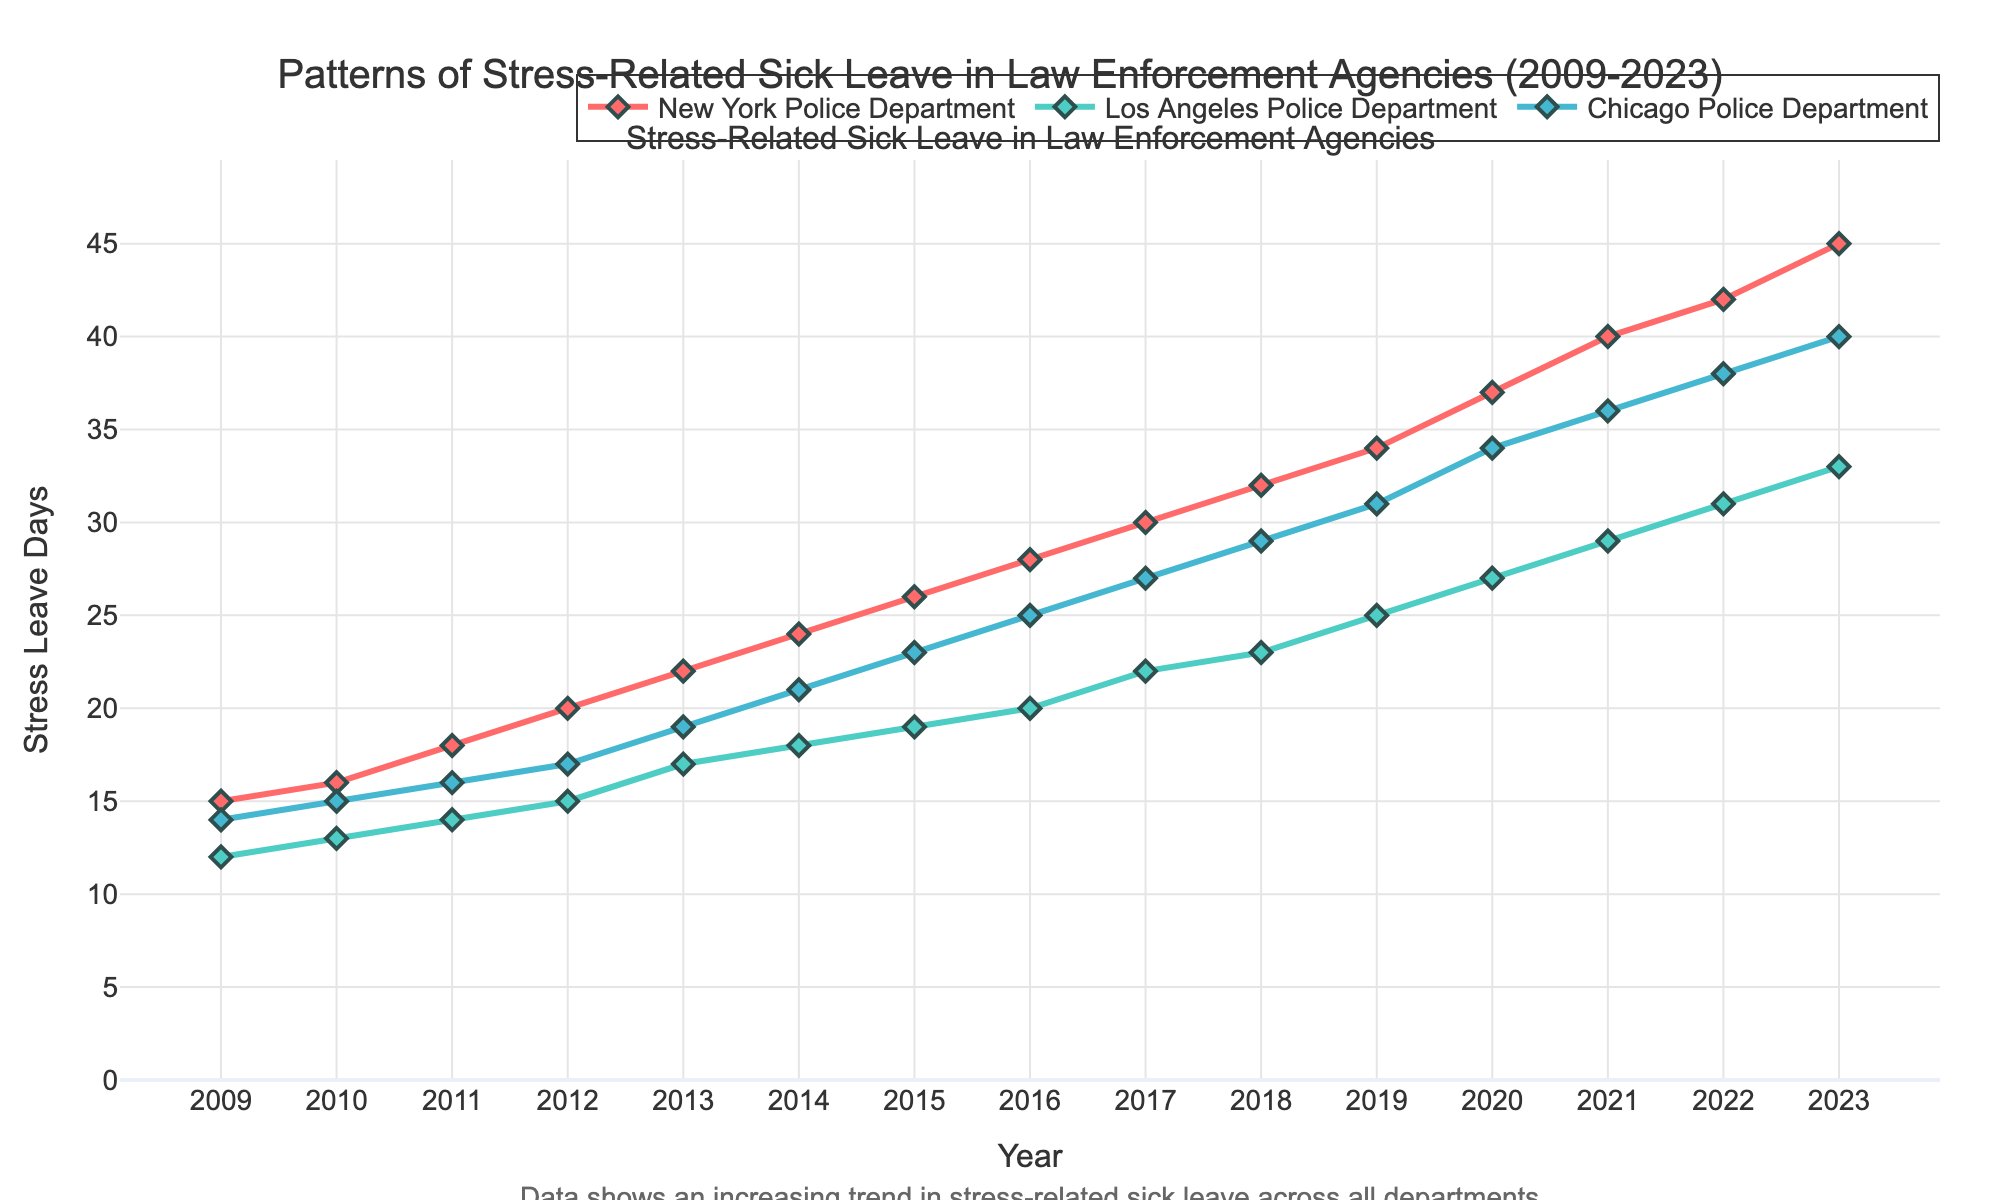What is the title of the plot? The title is displayed at the top center of the plot. It reads "Patterns of Stress-Related Sick Leave in Law Enforcement Agencies (2009-2023)"
Answer: Patterns of Stress-Related Sick Leave in Law Enforcement Agencies (2009-2023) Which department had the highest number of stress leave days in 2023? By looking at the data points for 2023 on the x-axis, the New York Police Department's line peaks the highest at 45 days
Answer: New York Police Department Is there a trend visible in the number of stress-related sick leave days over the years across all departments? All lines for the departments show an upward trend from 2009 to 2023, indicating an overall increase in stress-related sick leave days
Answer: Yes, an upward trend is visible What year did the Los Angeles Police Department see a peak in stress leave days, and how many days was it? Locate the highest point for the Los Angeles Police Department's line (colored in the provided figure) and read off the corresponding year and number of days. The peak occurred in 2023 with 33 days
Answer: 2023, 33 days How does the increase in stress leave days from 2009 to 2023 for the New York Police Department compare to that of the Chicago Police Department? Calculate the difference for both departments: 
- For NYPD: 45 (2023) - 15 (2009) = 30 days
- For CPD: 40 (2023) - 14 (2009) = 26 days
The increase for the NYPD is 30 days, while the increase for the CPD is 26 days. Thus, NYPD shows a greater increase
Answer: NYPD: 30 days, CPD: 26 days, NYPD shows a greater increase What is the average number of stress leave days taken in 2015 across all three departments? Sum the 2015 values for all three departments and divide by three: (26 + 19 + 23) / 3 = 68 / 3 = 22.67 days
Answer: 22.67 days Which department had the smallest increase in stress leave days between 2011 and 2016, and what was the difference? Calculate the difference for each department:
- NYPD: 28 - 18 = 10 days
- LAPD: 20 - 14 = 6 days
- CPD: 25 - 16 = 9 days
Los Angeles Police Department had the smallest increase with 6 days
Answer: Los Angeles Police Department, 6 days Is there any year where the stress leave days for the Los Angeles Police Department did not increase compared to the previous year? Go through the data points on the line for LAPD. Each year's value increases from the previous year, so there are no years where it did not increase
Answer: No 